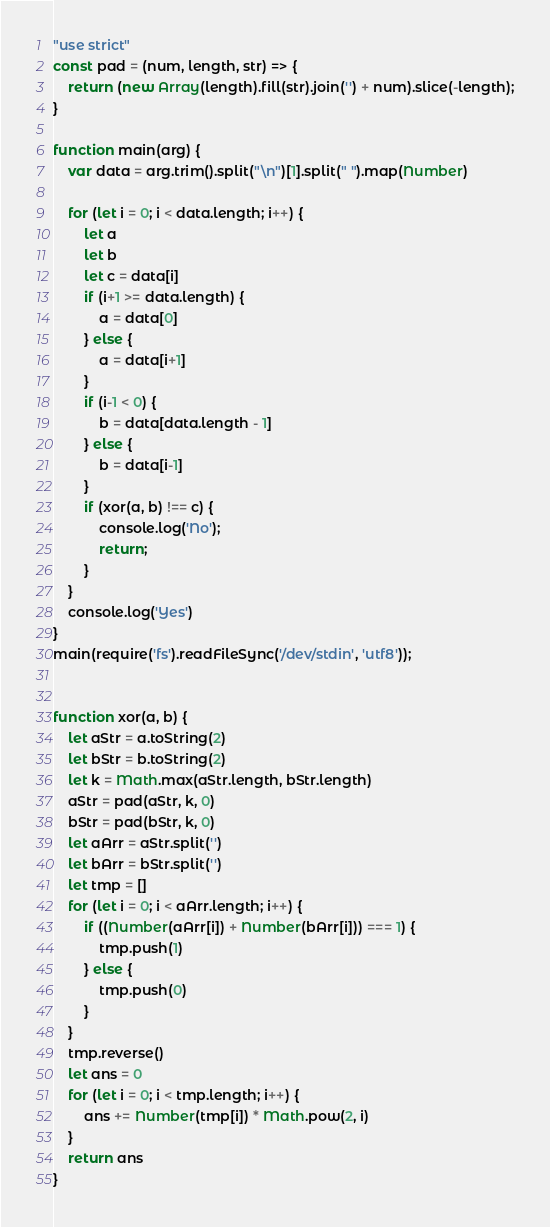Convert code to text. <code><loc_0><loc_0><loc_500><loc_500><_JavaScript_>"use strict"
const pad = (num, length, str) => {
    return (new Array(length).fill(str).join('') + num).slice(-length);
}

function main(arg) {
    var data = arg.trim().split("\n")[1].split(" ").map(Number)

    for (let i = 0; i < data.length; i++) {
        let a
        let b
        let c = data[i]
        if (i+1 >= data.length) {
            a = data[0]
        } else {
            a = data[i+1]
        }
        if (i-1 < 0) {
            b = data[data.length - 1]
        } else {
            b = data[i-1]
        }
        if (xor(a, b) !== c) {
            console.log('No');
            return;
        }
    }
    console.log('Yes')
}
main(require('fs').readFileSync('/dev/stdin', 'utf8'));


function xor(a, b) {
    let aStr = a.toString(2)
    let bStr = b.toString(2)
    let k = Math.max(aStr.length, bStr.length)
    aStr = pad(aStr, k, 0)
    bStr = pad(bStr, k, 0)
    let aArr = aStr.split('')
    let bArr = bStr.split('')
    let tmp = []
    for (let i = 0; i < aArr.length; i++) {
        if ((Number(aArr[i]) + Number(bArr[i])) === 1) {
            tmp.push(1)
        } else {
            tmp.push(0)
        }
    }
    tmp.reverse()
    let ans = 0
    for (let i = 0; i < tmp.length; i++) {
        ans += Number(tmp[i]) * Math.pow(2, i)
    }
    return ans
}</code> 